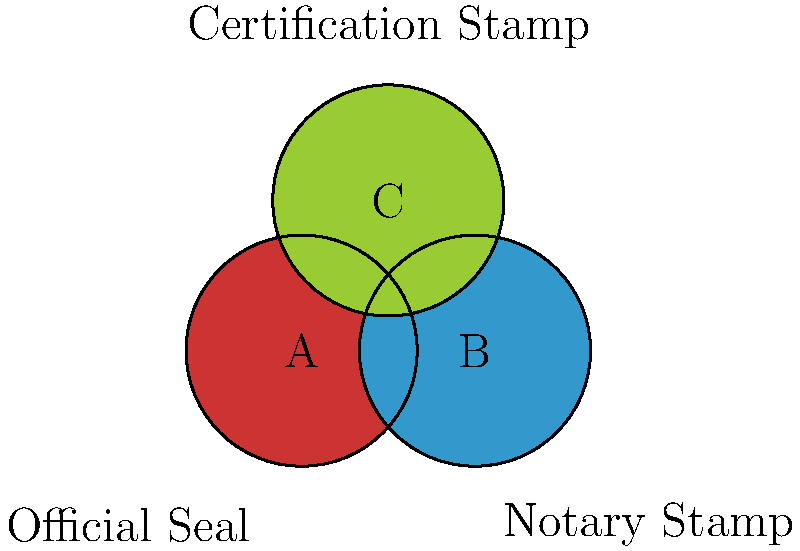In the image above, three different types of stamps or seals are represented by colored circles. Which combination of stamps would typically be required for a document to be considered officially certified and notarized for submission to the Dutch Senate? To determine the correct combination of stamps required for a document to be officially certified and notarized for submission to the Dutch Senate, let's analyze each stamp type:

1. Circle A (red): This represents an Official Seal, which is typically used by government agencies to authenticate documents.

2. Circle B (blue): This represents a Notary Stamp, which is used by notaries to verify the authenticity of signatures and documents.

3. Circle C (green): This represents a Certification Stamp, which is often used to certify copies of original documents.

For a document to be considered officially certified and notarized for submission to the Dutch Senate, it would typically require:

1. An Official Seal (A) to show that it has been authenticated by the appropriate government agency.
2. A Notary Stamp (B) to verify that the document has been properly notarized.

The Certification Stamp (C) may not be necessary in this case, as the Official Seal and Notary Stamp together provide sufficient authentication for most official purposes.

Therefore, the combination of stamps A (Official Seal) and B (Notary Stamp) would typically be required for a document to be considered officially certified and notarized for submission to the Dutch Senate.
Answer: A and B (Official Seal and Notary Stamp) 